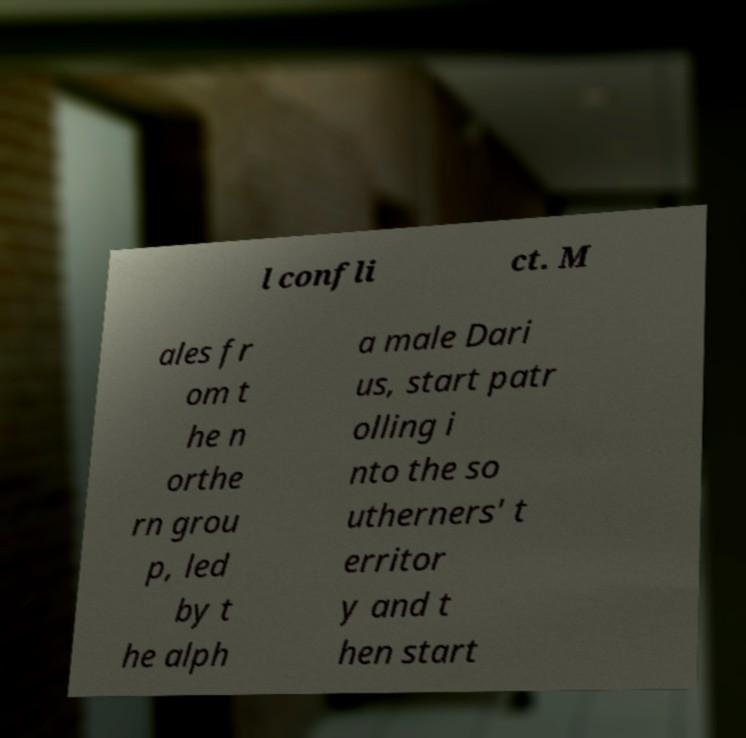For documentation purposes, I need the text within this image transcribed. Could you provide that? l confli ct. M ales fr om t he n orthe rn grou p, led by t he alph a male Dari us, start patr olling i nto the so utherners' t erritor y and t hen start 